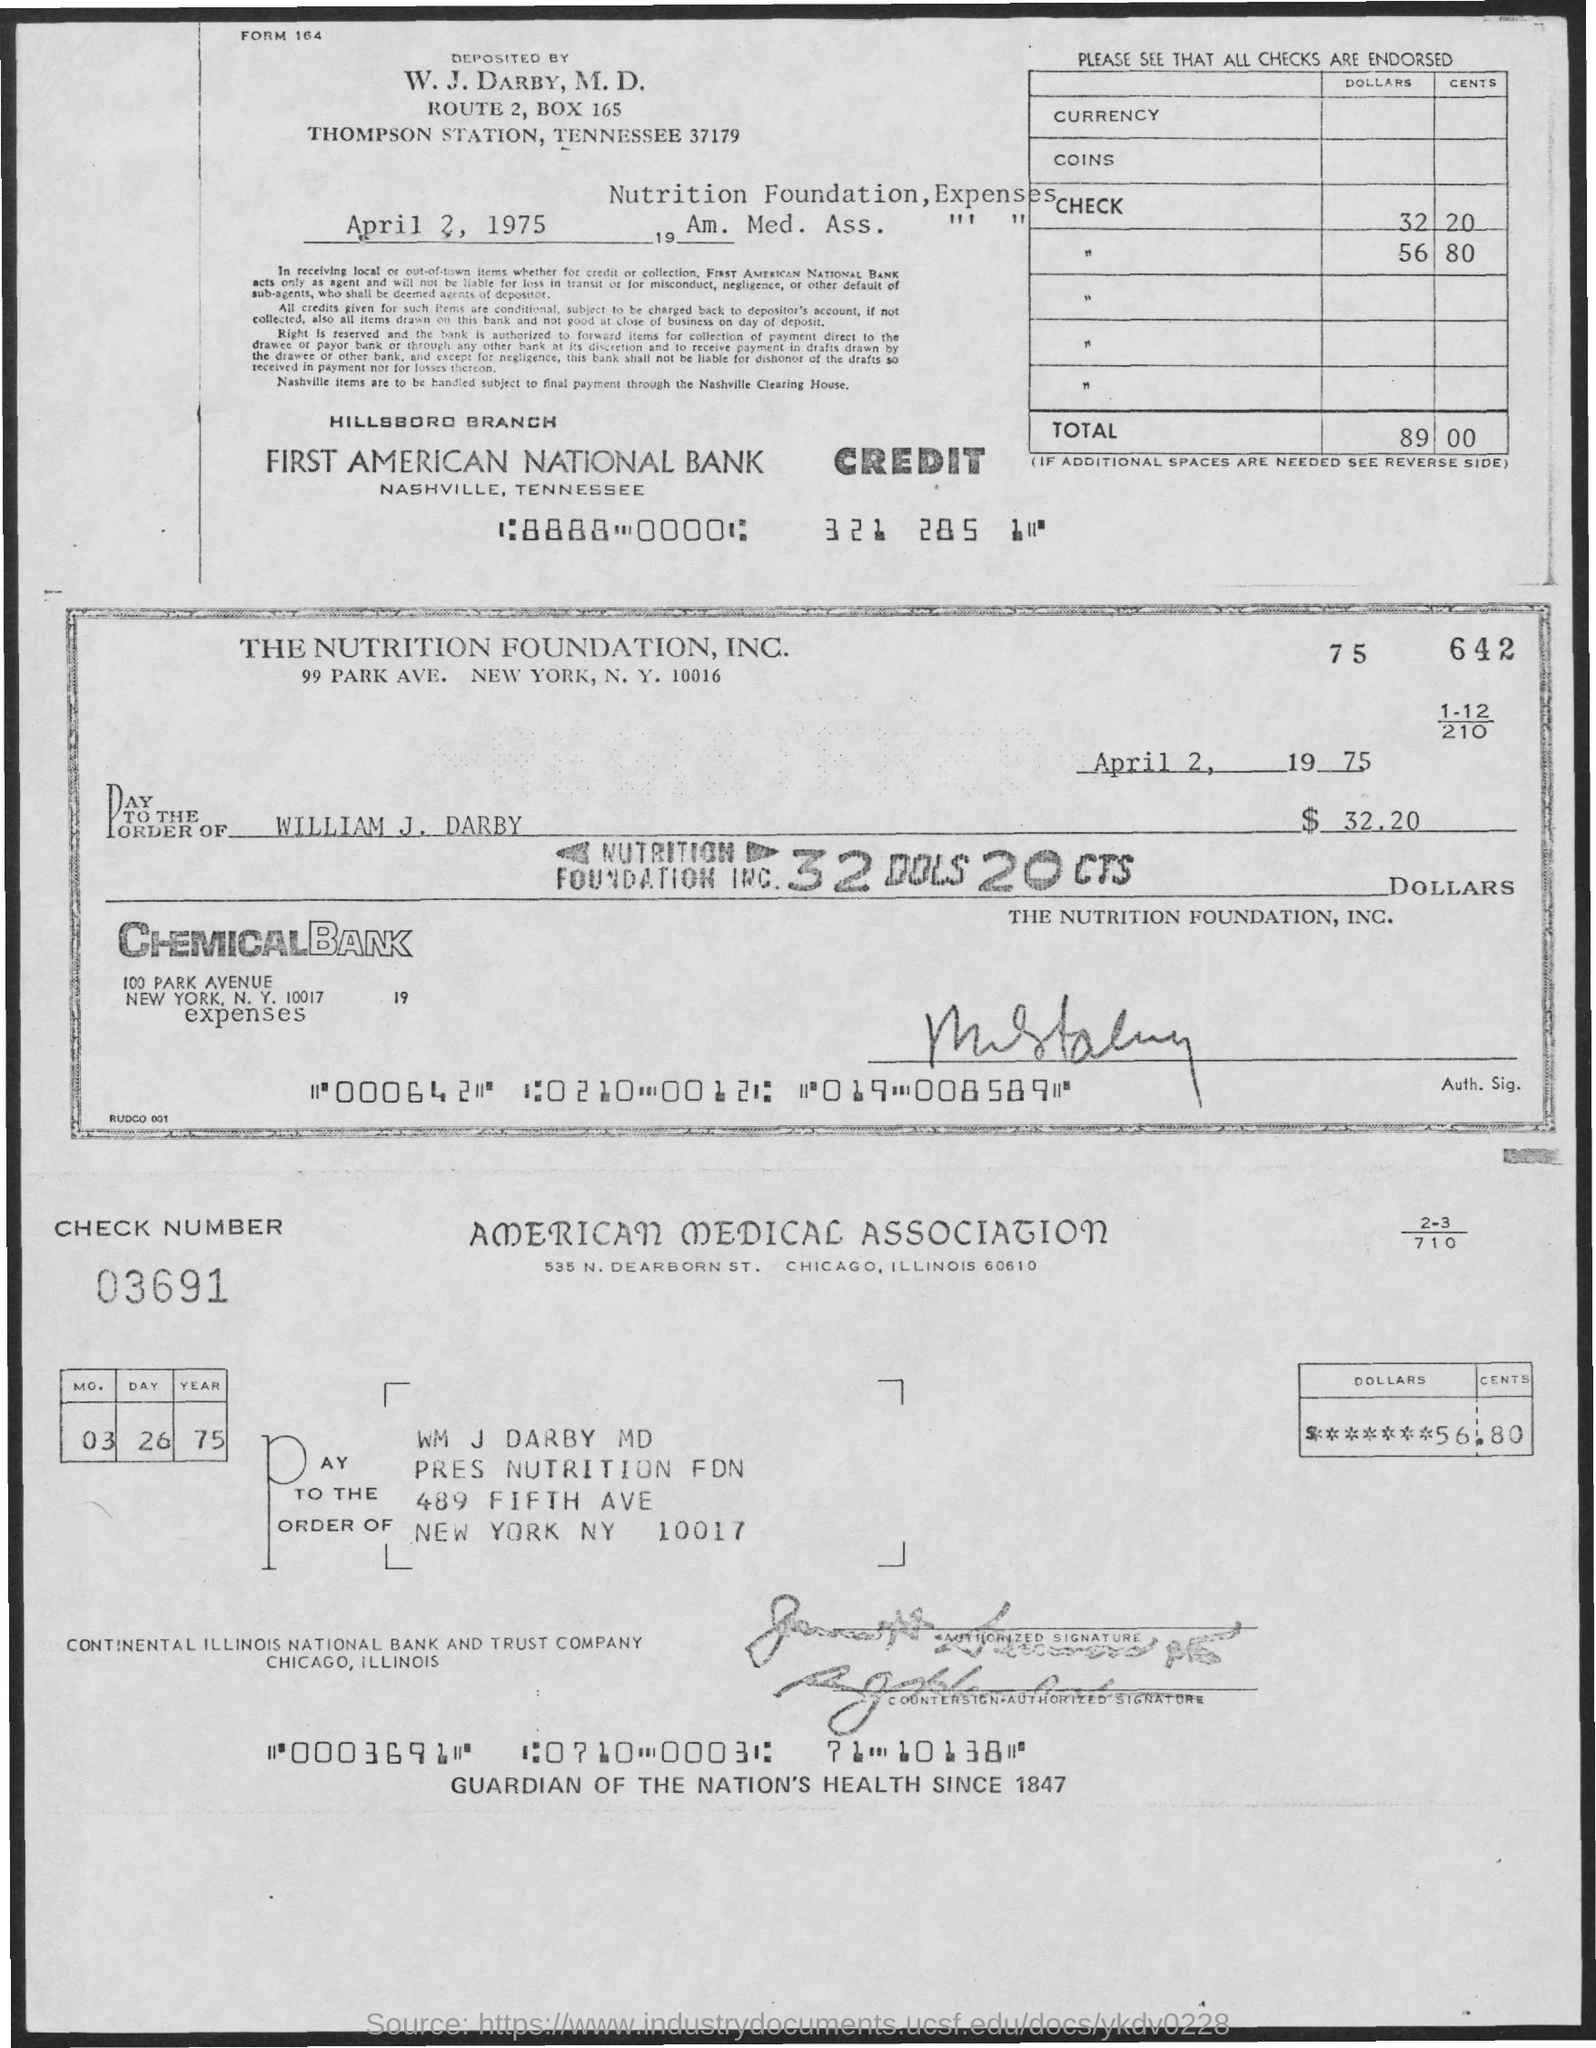What is the check number ?
Keep it short and to the point. 03691. What is the street address of the nutrition foundation, inc.?
Your answer should be very brief. 99 Park ave. What is the street address of american medical association ?
Your answer should be compact. 535 n. dearborn st. 